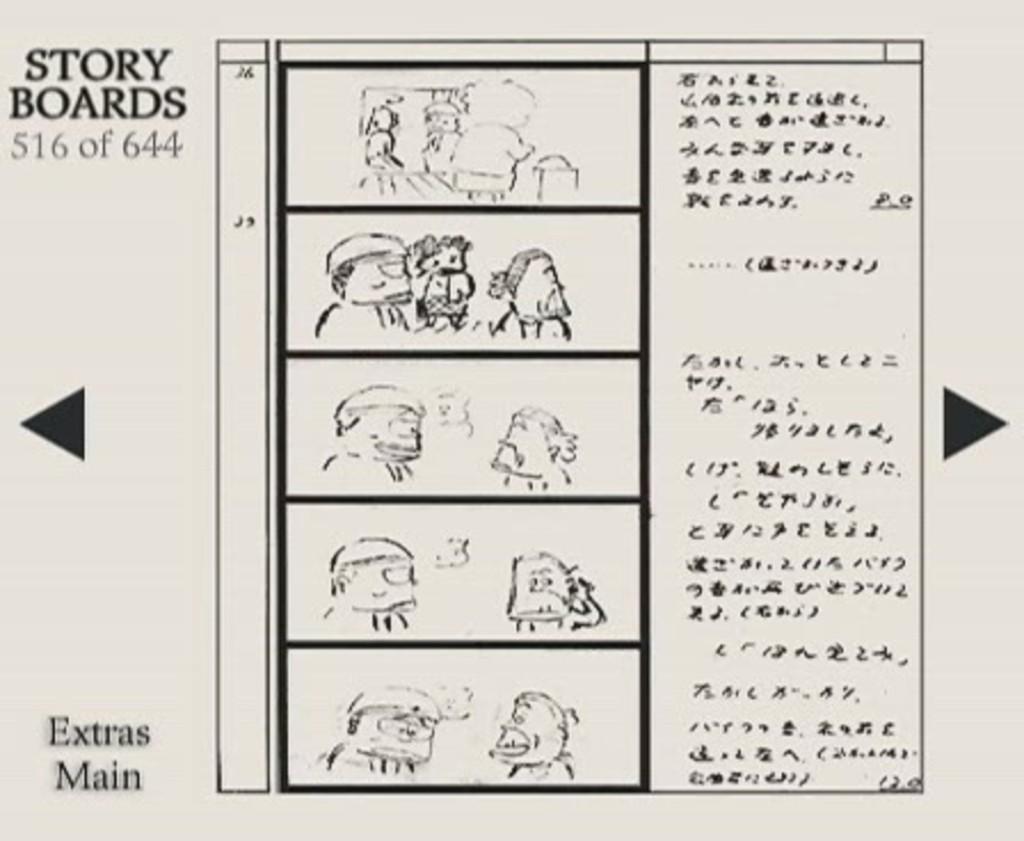Describe this image in one or two sentences. In this image I can see the paper. On the paper I can see the printed text and few images which are in black color. 